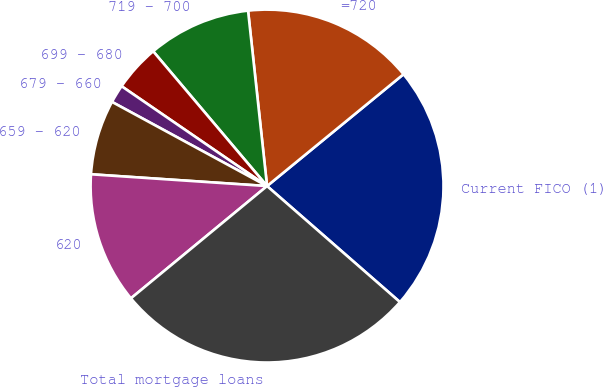<chart> <loc_0><loc_0><loc_500><loc_500><pie_chart><fcel>Current FICO (1)<fcel>=720<fcel>719 - 700<fcel>699 - 680<fcel>679 - 660<fcel>659 - 620<fcel>620<fcel>Total mortgage loans<nl><fcel>22.35%<fcel>15.79%<fcel>9.45%<fcel>4.26%<fcel>1.66%<fcel>6.85%<fcel>12.04%<fcel>27.6%<nl></chart> 